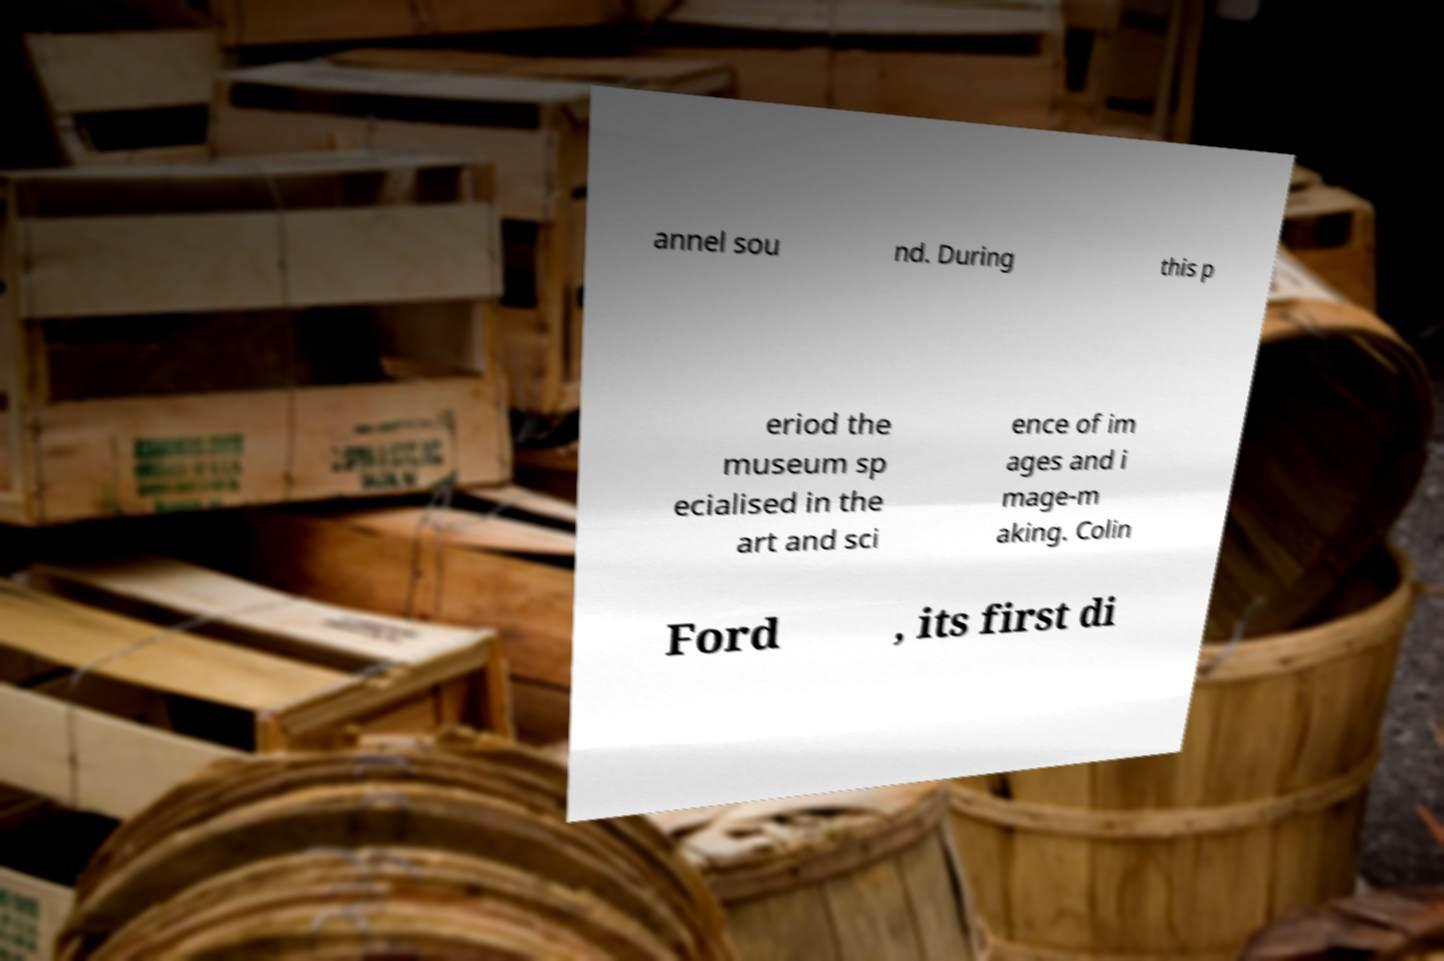For documentation purposes, I need the text within this image transcribed. Could you provide that? annel sou nd. During this p eriod the museum sp ecialised in the art and sci ence of im ages and i mage-m aking. Colin Ford , its first di 